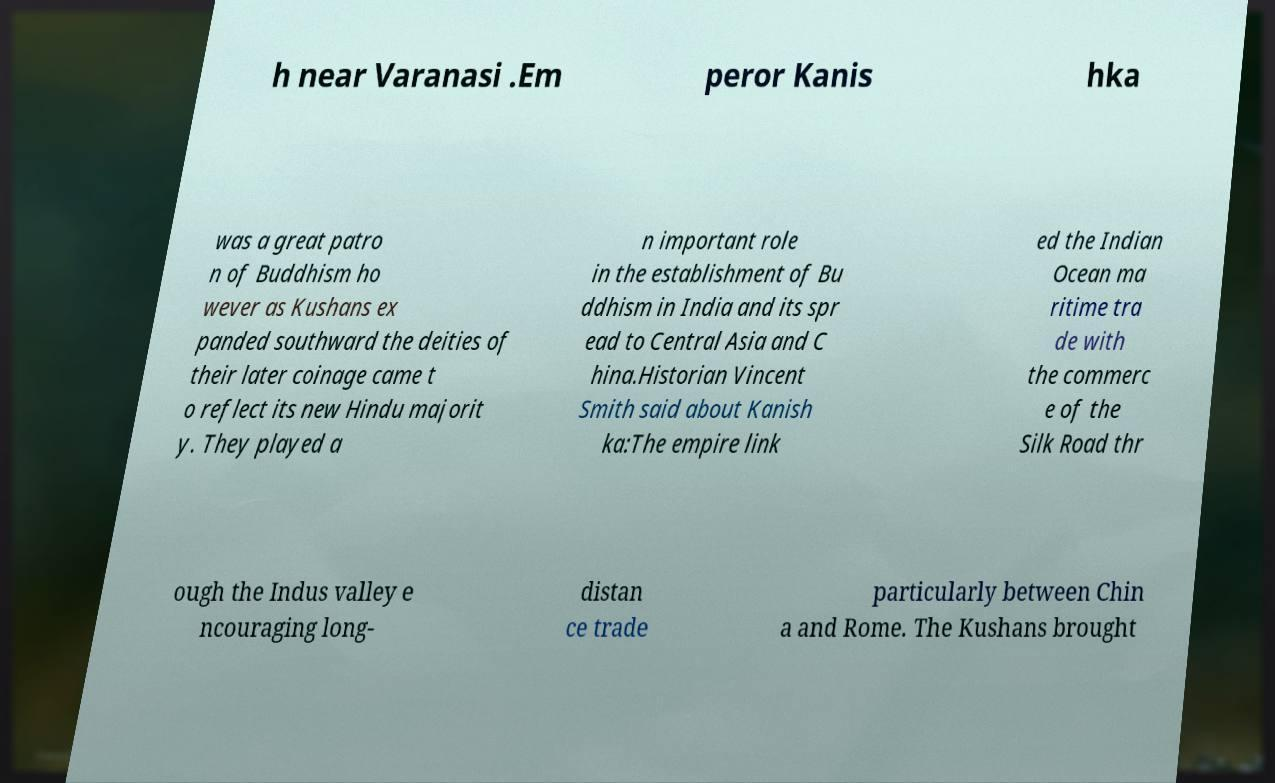Can you read and provide the text displayed in the image?This photo seems to have some interesting text. Can you extract and type it out for me? h near Varanasi .Em peror Kanis hka was a great patro n of Buddhism ho wever as Kushans ex panded southward the deities of their later coinage came t o reflect its new Hindu majorit y. They played a n important role in the establishment of Bu ddhism in India and its spr ead to Central Asia and C hina.Historian Vincent Smith said about Kanish ka:The empire link ed the Indian Ocean ma ritime tra de with the commerc e of the Silk Road thr ough the Indus valley e ncouraging long- distan ce trade particularly between Chin a and Rome. The Kushans brought 